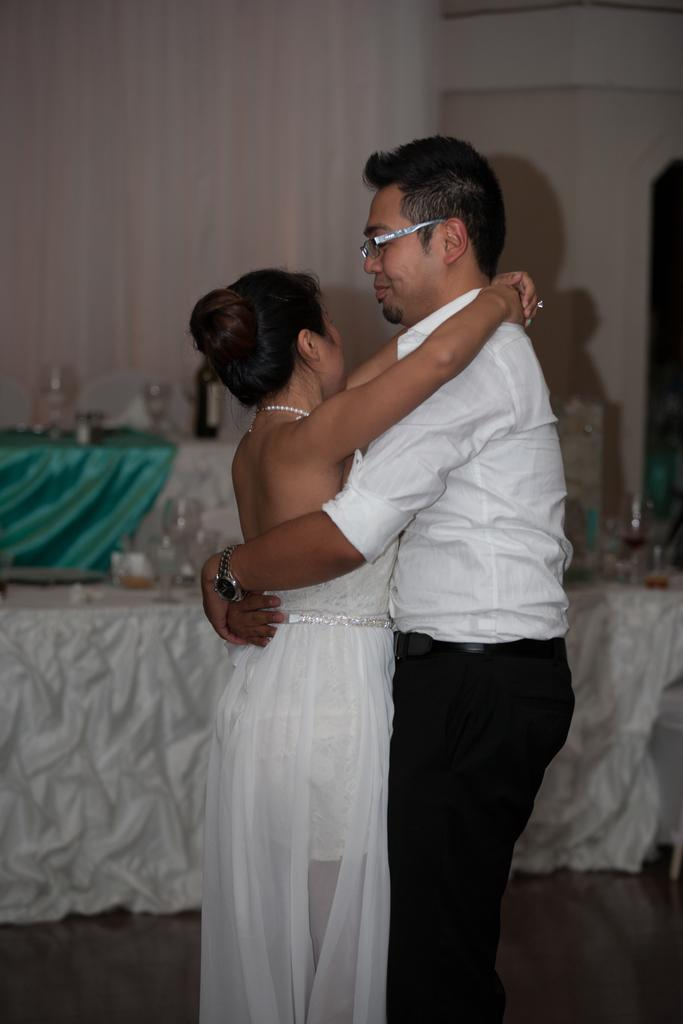How many people are in the image? There are two people in the image, a man and a woman. What is the man wearing in the image? The man is wearing spectacles in the image. What can be seen on the tables in the background of the image? There are glasses and other things on tables in the background of the image. What type of zinc is the man rubbing on the woman's forehead in the image? There is no zinc or rubbing action present in the image. 